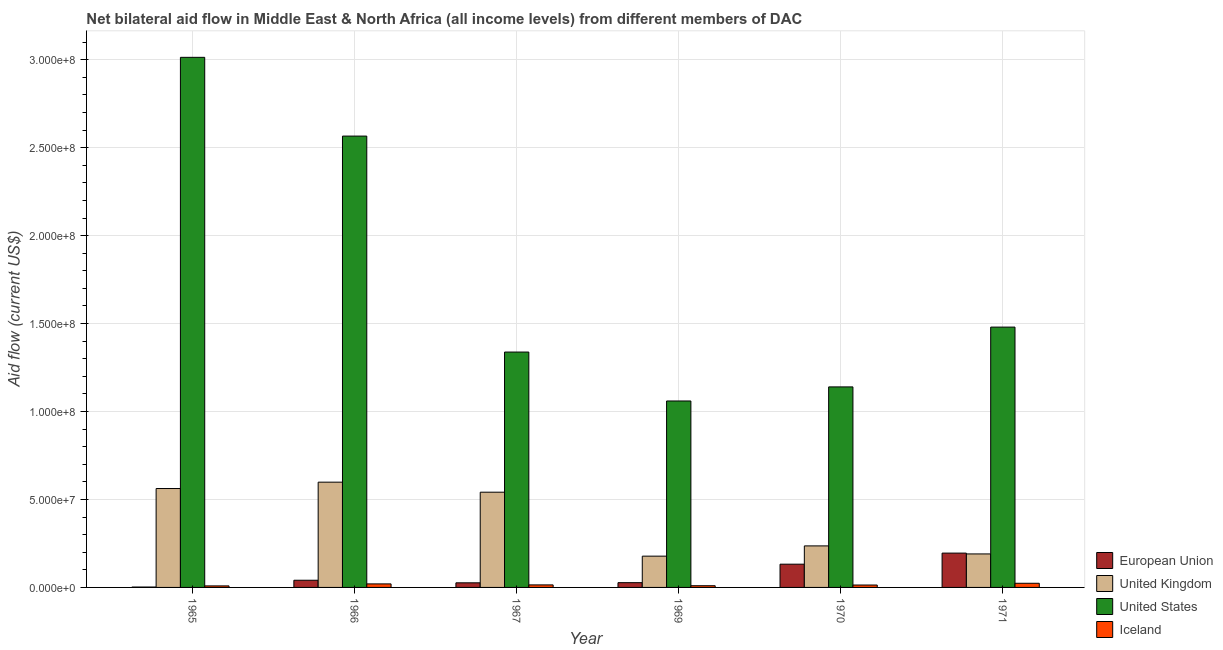How many groups of bars are there?
Your response must be concise. 6. How many bars are there on the 6th tick from the right?
Your answer should be compact. 4. What is the label of the 1st group of bars from the left?
Ensure brevity in your answer.  1965. In how many cases, is the number of bars for a given year not equal to the number of legend labels?
Your answer should be compact. 0. What is the amount of aid given by uk in 1965?
Ensure brevity in your answer.  5.62e+07. Across all years, what is the maximum amount of aid given by uk?
Offer a very short reply. 5.98e+07. Across all years, what is the minimum amount of aid given by eu?
Make the answer very short. 2.20e+05. In which year was the amount of aid given by us maximum?
Your answer should be very brief. 1965. In which year was the amount of aid given by eu minimum?
Ensure brevity in your answer.  1965. What is the total amount of aid given by uk in the graph?
Ensure brevity in your answer.  2.31e+08. What is the difference between the amount of aid given by uk in 1970 and that in 1971?
Provide a short and direct response. 4.57e+06. What is the difference between the amount of aid given by us in 1970 and the amount of aid given by uk in 1966?
Provide a short and direct response. -1.43e+08. What is the average amount of aid given by us per year?
Make the answer very short. 1.77e+08. In how many years, is the amount of aid given by iceland greater than 190000000 US$?
Your response must be concise. 0. What is the ratio of the amount of aid given by us in 1970 to that in 1971?
Ensure brevity in your answer.  0.77. What is the difference between the highest and the second highest amount of aid given by us?
Provide a short and direct response. 4.48e+07. What is the difference between the highest and the lowest amount of aid given by iceland?
Ensure brevity in your answer.  1.49e+06. Is it the case that in every year, the sum of the amount of aid given by uk and amount of aid given by eu is greater than the sum of amount of aid given by us and amount of aid given by iceland?
Make the answer very short. No. What does the 1st bar from the left in 1965 represents?
Your answer should be very brief. European Union. Is it the case that in every year, the sum of the amount of aid given by eu and amount of aid given by uk is greater than the amount of aid given by us?
Your answer should be compact. No. What is the difference between two consecutive major ticks on the Y-axis?
Offer a terse response. 5.00e+07. How are the legend labels stacked?
Your answer should be compact. Vertical. What is the title of the graph?
Your response must be concise. Net bilateral aid flow in Middle East & North Africa (all income levels) from different members of DAC. Does "Environmental sustainability" appear as one of the legend labels in the graph?
Make the answer very short. No. What is the label or title of the X-axis?
Your answer should be very brief. Year. What is the Aid flow (current US$) in European Union in 1965?
Your answer should be very brief. 2.20e+05. What is the Aid flow (current US$) in United Kingdom in 1965?
Provide a succinct answer. 5.62e+07. What is the Aid flow (current US$) in United States in 1965?
Make the answer very short. 3.01e+08. What is the Aid flow (current US$) in Iceland in 1965?
Give a very brief answer. 8.70e+05. What is the Aid flow (current US$) in European Union in 1966?
Offer a terse response. 4.08e+06. What is the Aid flow (current US$) in United Kingdom in 1966?
Keep it short and to the point. 5.98e+07. What is the Aid flow (current US$) in United States in 1966?
Your answer should be compact. 2.57e+08. What is the Aid flow (current US$) of Iceland in 1966?
Provide a short and direct response. 2.01e+06. What is the Aid flow (current US$) in European Union in 1967?
Ensure brevity in your answer.  2.62e+06. What is the Aid flow (current US$) in United Kingdom in 1967?
Provide a short and direct response. 5.41e+07. What is the Aid flow (current US$) of United States in 1967?
Ensure brevity in your answer.  1.34e+08. What is the Aid flow (current US$) of Iceland in 1967?
Your answer should be very brief. 1.44e+06. What is the Aid flow (current US$) in European Union in 1969?
Your answer should be compact. 2.71e+06. What is the Aid flow (current US$) in United Kingdom in 1969?
Ensure brevity in your answer.  1.78e+07. What is the Aid flow (current US$) in United States in 1969?
Offer a terse response. 1.06e+08. What is the Aid flow (current US$) in Iceland in 1969?
Offer a very short reply. 9.70e+05. What is the Aid flow (current US$) of European Union in 1970?
Your answer should be compact. 1.32e+07. What is the Aid flow (current US$) in United Kingdom in 1970?
Ensure brevity in your answer.  2.36e+07. What is the Aid flow (current US$) of United States in 1970?
Keep it short and to the point. 1.14e+08. What is the Aid flow (current US$) in Iceland in 1970?
Make the answer very short. 1.37e+06. What is the Aid flow (current US$) of European Union in 1971?
Your answer should be very brief. 1.95e+07. What is the Aid flow (current US$) in United Kingdom in 1971?
Your response must be concise. 1.90e+07. What is the Aid flow (current US$) in United States in 1971?
Keep it short and to the point. 1.48e+08. What is the Aid flow (current US$) in Iceland in 1971?
Your answer should be compact. 2.36e+06. Across all years, what is the maximum Aid flow (current US$) in European Union?
Your response must be concise. 1.95e+07. Across all years, what is the maximum Aid flow (current US$) in United Kingdom?
Your answer should be compact. 5.98e+07. Across all years, what is the maximum Aid flow (current US$) in United States?
Give a very brief answer. 3.01e+08. Across all years, what is the maximum Aid flow (current US$) of Iceland?
Offer a terse response. 2.36e+06. Across all years, what is the minimum Aid flow (current US$) of European Union?
Your answer should be very brief. 2.20e+05. Across all years, what is the minimum Aid flow (current US$) of United Kingdom?
Your answer should be compact. 1.78e+07. Across all years, what is the minimum Aid flow (current US$) of United States?
Ensure brevity in your answer.  1.06e+08. Across all years, what is the minimum Aid flow (current US$) of Iceland?
Provide a succinct answer. 8.70e+05. What is the total Aid flow (current US$) in European Union in the graph?
Provide a succinct answer. 4.24e+07. What is the total Aid flow (current US$) of United Kingdom in the graph?
Your answer should be very brief. 2.31e+08. What is the total Aid flow (current US$) of United States in the graph?
Give a very brief answer. 1.06e+09. What is the total Aid flow (current US$) of Iceland in the graph?
Offer a very short reply. 9.02e+06. What is the difference between the Aid flow (current US$) of European Union in 1965 and that in 1966?
Make the answer very short. -3.86e+06. What is the difference between the Aid flow (current US$) of United Kingdom in 1965 and that in 1966?
Provide a succinct answer. -3.61e+06. What is the difference between the Aid flow (current US$) of United States in 1965 and that in 1966?
Give a very brief answer. 4.48e+07. What is the difference between the Aid flow (current US$) in Iceland in 1965 and that in 1966?
Your response must be concise. -1.14e+06. What is the difference between the Aid flow (current US$) in European Union in 1965 and that in 1967?
Offer a terse response. -2.40e+06. What is the difference between the Aid flow (current US$) in United Kingdom in 1965 and that in 1967?
Give a very brief answer. 2.09e+06. What is the difference between the Aid flow (current US$) of United States in 1965 and that in 1967?
Your answer should be compact. 1.68e+08. What is the difference between the Aid flow (current US$) of Iceland in 1965 and that in 1967?
Offer a very short reply. -5.70e+05. What is the difference between the Aid flow (current US$) of European Union in 1965 and that in 1969?
Give a very brief answer. -2.49e+06. What is the difference between the Aid flow (current US$) in United Kingdom in 1965 and that in 1969?
Your answer should be very brief. 3.84e+07. What is the difference between the Aid flow (current US$) of United States in 1965 and that in 1969?
Provide a short and direct response. 1.95e+08. What is the difference between the Aid flow (current US$) in Iceland in 1965 and that in 1969?
Make the answer very short. -1.00e+05. What is the difference between the Aid flow (current US$) in European Union in 1965 and that in 1970?
Offer a terse response. -1.30e+07. What is the difference between the Aid flow (current US$) of United Kingdom in 1965 and that in 1970?
Offer a very short reply. 3.26e+07. What is the difference between the Aid flow (current US$) of United States in 1965 and that in 1970?
Provide a succinct answer. 1.87e+08. What is the difference between the Aid flow (current US$) in Iceland in 1965 and that in 1970?
Your answer should be compact. -5.00e+05. What is the difference between the Aid flow (current US$) in European Union in 1965 and that in 1971?
Your response must be concise. -1.93e+07. What is the difference between the Aid flow (current US$) in United Kingdom in 1965 and that in 1971?
Give a very brief answer. 3.72e+07. What is the difference between the Aid flow (current US$) of United States in 1965 and that in 1971?
Your answer should be compact. 1.53e+08. What is the difference between the Aid flow (current US$) in Iceland in 1965 and that in 1971?
Give a very brief answer. -1.49e+06. What is the difference between the Aid flow (current US$) in European Union in 1966 and that in 1967?
Make the answer very short. 1.46e+06. What is the difference between the Aid flow (current US$) in United Kingdom in 1966 and that in 1967?
Offer a very short reply. 5.70e+06. What is the difference between the Aid flow (current US$) in United States in 1966 and that in 1967?
Give a very brief answer. 1.23e+08. What is the difference between the Aid flow (current US$) of Iceland in 1966 and that in 1967?
Your answer should be very brief. 5.70e+05. What is the difference between the Aid flow (current US$) of European Union in 1966 and that in 1969?
Offer a terse response. 1.37e+06. What is the difference between the Aid flow (current US$) in United Kingdom in 1966 and that in 1969?
Make the answer very short. 4.21e+07. What is the difference between the Aid flow (current US$) of United States in 1966 and that in 1969?
Your response must be concise. 1.51e+08. What is the difference between the Aid flow (current US$) of Iceland in 1966 and that in 1969?
Provide a short and direct response. 1.04e+06. What is the difference between the Aid flow (current US$) in European Union in 1966 and that in 1970?
Offer a terse response. -9.14e+06. What is the difference between the Aid flow (current US$) of United Kingdom in 1966 and that in 1970?
Offer a terse response. 3.62e+07. What is the difference between the Aid flow (current US$) in United States in 1966 and that in 1970?
Give a very brief answer. 1.43e+08. What is the difference between the Aid flow (current US$) in Iceland in 1966 and that in 1970?
Your answer should be compact. 6.40e+05. What is the difference between the Aid flow (current US$) in European Union in 1966 and that in 1971?
Give a very brief answer. -1.54e+07. What is the difference between the Aid flow (current US$) of United Kingdom in 1966 and that in 1971?
Offer a very short reply. 4.08e+07. What is the difference between the Aid flow (current US$) of United States in 1966 and that in 1971?
Provide a short and direct response. 1.09e+08. What is the difference between the Aid flow (current US$) of Iceland in 1966 and that in 1971?
Ensure brevity in your answer.  -3.50e+05. What is the difference between the Aid flow (current US$) in United Kingdom in 1967 and that in 1969?
Give a very brief answer. 3.64e+07. What is the difference between the Aid flow (current US$) in United States in 1967 and that in 1969?
Keep it short and to the point. 2.78e+07. What is the difference between the Aid flow (current US$) in European Union in 1967 and that in 1970?
Ensure brevity in your answer.  -1.06e+07. What is the difference between the Aid flow (current US$) of United Kingdom in 1967 and that in 1970?
Offer a terse response. 3.05e+07. What is the difference between the Aid flow (current US$) in United States in 1967 and that in 1970?
Your response must be concise. 1.98e+07. What is the difference between the Aid flow (current US$) of European Union in 1967 and that in 1971?
Offer a terse response. -1.69e+07. What is the difference between the Aid flow (current US$) in United Kingdom in 1967 and that in 1971?
Offer a terse response. 3.51e+07. What is the difference between the Aid flow (current US$) in United States in 1967 and that in 1971?
Make the answer very short. -1.42e+07. What is the difference between the Aid flow (current US$) in Iceland in 1967 and that in 1971?
Make the answer very short. -9.20e+05. What is the difference between the Aid flow (current US$) in European Union in 1969 and that in 1970?
Offer a very short reply. -1.05e+07. What is the difference between the Aid flow (current US$) in United Kingdom in 1969 and that in 1970?
Your answer should be compact. -5.83e+06. What is the difference between the Aid flow (current US$) in United States in 1969 and that in 1970?
Keep it short and to the point. -8.00e+06. What is the difference between the Aid flow (current US$) in Iceland in 1969 and that in 1970?
Give a very brief answer. -4.00e+05. What is the difference between the Aid flow (current US$) of European Union in 1969 and that in 1971?
Keep it short and to the point. -1.68e+07. What is the difference between the Aid flow (current US$) in United Kingdom in 1969 and that in 1971?
Give a very brief answer. -1.26e+06. What is the difference between the Aid flow (current US$) of United States in 1969 and that in 1971?
Your answer should be compact. -4.20e+07. What is the difference between the Aid flow (current US$) in Iceland in 1969 and that in 1971?
Make the answer very short. -1.39e+06. What is the difference between the Aid flow (current US$) of European Union in 1970 and that in 1971?
Provide a short and direct response. -6.29e+06. What is the difference between the Aid flow (current US$) in United Kingdom in 1970 and that in 1971?
Your answer should be compact. 4.57e+06. What is the difference between the Aid flow (current US$) of United States in 1970 and that in 1971?
Your answer should be compact. -3.40e+07. What is the difference between the Aid flow (current US$) in Iceland in 1970 and that in 1971?
Keep it short and to the point. -9.90e+05. What is the difference between the Aid flow (current US$) in European Union in 1965 and the Aid flow (current US$) in United Kingdom in 1966?
Offer a very short reply. -5.96e+07. What is the difference between the Aid flow (current US$) in European Union in 1965 and the Aid flow (current US$) in United States in 1966?
Your answer should be compact. -2.56e+08. What is the difference between the Aid flow (current US$) of European Union in 1965 and the Aid flow (current US$) of Iceland in 1966?
Provide a succinct answer. -1.79e+06. What is the difference between the Aid flow (current US$) in United Kingdom in 1965 and the Aid flow (current US$) in United States in 1966?
Make the answer very short. -2.00e+08. What is the difference between the Aid flow (current US$) in United Kingdom in 1965 and the Aid flow (current US$) in Iceland in 1966?
Your response must be concise. 5.42e+07. What is the difference between the Aid flow (current US$) of United States in 1965 and the Aid flow (current US$) of Iceland in 1966?
Make the answer very short. 2.99e+08. What is the difference between the Aid flow (current US$) of European Union in 1965 and the Aid flow (current US$) of United Kingdom in 1967?
Make the answer very short. -5.39e+07. What is the difference between the Aid flow (current US$) in European Union in 1965 and the Aid flow (current US$) in United States in 1967?
Provide a succinct answer. -1.34e+08. What is the difference between the Aid flow (current US$) in European Union in 1965 and the Aid flow (current US$) in Iceland in 1967?
Ensure brevity in your answer.  -1.22e+06. What is the difference between the Aid flow (current US$) of United Kingdom in 1965 and the Aid flow (current US$) of United States in 1967?
Make the answer very short. -7.76e+07. What is the difference between the Aid flow (current US$) in United Kingdom in 1965 and the Aid flow (current US$) in Iceland in 1967?
Provide a short and direct response. 5.48e+07. What is the difference between the Aid flow (current US$) in United States in 1965 and the Aid flow (current US$) in Iceland in 1967?
Keep it short and to the point. 3.00e+08. What is the difference between the Aid flow (current US$) of European Union in 1965 and the Aid flow (current US$) of United Kingdom in 1969?
Offer a terse response. -1.76e+07. What is the difference between the Aid flow (current US$) of European Union in 1965 and the Aid flow (current US$) of United States in 1969?
Ensure brevity in your answer.  -1.06e+08. What is the difference between the Aid flow (current US$) in European Union in 1965 and the Aid flow (current US$) in Iceland in 1969?
Keep it short and to the point. -7.50e+05. What is the difference between the Aid flow (current US$) of United Kingdom in 1965 and the Aid flow (current US$) of United States in 1969?
Give a very brief answer. -4.98e+07. What is the difference between the Aid flow (current US$) of United Kingdom in 1965 and the Aid flow (current US$) of Iceland in 1969?
Keep it short and to the point. 5.53e+07. What is the difference between the Aid flow (current US$) in United States in 1965 and the Aid flow (current US$) in Iceland in 1969?
Provide a succinct answer. 3.00e+08. What is the difference between the Aid flow (current US$) of European Union in 1965 and the Aid flow (current US$) of United Kingdom in 1970?
Your answer should be very brief. -2.34e+07. What is the difference between the Aid flow (current US$) of European Union in 1965 and the Aid flow (current US$) of United States in 1970?
Offer a terse response. -1.14e+08. What is the difference between the Aid flow (current US$) of European Union in 1965 and the Aid flow (current US$) of Iceland in 1970?
Provide a short and direct response. -1.15e+06. What is the difference between the Aid flow (current US$) in United Kingdom in 1965 and the Aid flow (current US$) in United States in 1970?
Provide a succinct answer. -5.78e+07. What is the difference between the Aid flow (current US$) of United Kingdom in 1965 and the Aid flow (current US$) of Iceland in 1970?
Give a very brief answer. 5.49e+07. What is the difference between the Aid flow (current US$) of United States in 1965 and the Aid flow (current US$) of Iceland in 1970?
Ensure brevity in your answer.  3.00e+08. What is the difference between the Aid flow (current US$) of European Union in 1965 and the Aid flow (current US$) of United Kingdom in 1971?
Your answer should be compact. -1.88e+07. What is the difference between the Aid flow (current US$) in European Union in 1965 and the Aid flow (current US$) in United States in 1971?
Give a very brief answer. -1.48e+08. What is the difference between the Aid flow (current US$) of European Union in 1965 and the Aid flow (current US$) of Iceland in 1971?
Your answer should be very brief. -2.14e+06. What is the difference between the Aid flow (current US$) in United Kingdom in 1965 and the Aid flow (current US$) in United States in 1971?
Your answer should be compact. -9.18e+07. What is the difference between the Aid flow (current US$) of United Kingdom in 1965 and the Aid flow (current US$) of Iceland in 1971?
Keep it short and to the point. 5.39e+07. What is the difference between the Aid flow (current US$) in United States in 1965 and the Aid flow (current US$) in Iceland in 1971?
Make the answer very short. 2.99e+08. What is the difference between the Aid flow (current US$) in European Union in 1966 and the Aid flow (current US$) in United Kingdom in 1967?
Give a very brief answer. -5.01e+07. What is the difference between the Aid flow (current US$) in European Union in 1966 and the Aid flow (current US$) in United States in 1967?
Your response must be concise. -1.30e+08. What is the difference between the Aid flow (current US$) in European Union in 1966 and the Aid flow (current US$) in Iceland in 1967?
Your answer should be compact. 2.64e+06. What is the difference between the Aid flow (current US$) of United Kingdom in 1966 and the Aid flow (current US$) of United States in 1967?
Provide a succinct answer. -7.40e+07. What is the difference between the Aid flow (current US$) in United Kingdom in 1966 and the Aid flow (current US$) in Iceland in 1967?
Your answer should be compact. 5.84e+07. What is the difference between the Aid flow (current US$) of United States in 1966 and the Aid flow (current US$) of Iceland in 1967?
Offer a terse response. 2.55e+08. What is the difference between the Aid flow (current US$) in European Union in 1966 and the Aid flow (current US$) in United Kingdom in 1969?
Offer a terse response. -1.37e+07. What is the difference between the Aid flow (current US$) in European Union in 1966 and the Aid flow (current US$) in United States in 1969?
Provide a short and direct response. -1.02e+08. What is the difference between the Aid flow (current US$) in European Union in 1966 and the Aid flow (current US$) in Iceland in 1969?
Your answer should be compact. 3.11e+06. What is the difference between the Aid flow (current US$) of United Kingdom in 1966 and the Aid flow (current US$) of United States in 1969?
Your answer should be very brief. -4.62e+07. What is the difference between the Aid flow (current US$) of United Kingdom in 1966 and the Aid flow (current US$) of Iceland in 1969?
Give a very brief answer. 5.89e+07. What is the difference between the Aid flow (current US$) of United States in 1966 and the Aid flow (current US$) of Iceland in 1969?
Offer a terse response. 2.56e+08. What is the difference between the Aid flow (current US$) of European Union in 1966 and the Aid flow (current US$) of United Kingdom in 1970?
Provide a short and direct response. -1.95e+07. What is the difference between the Aid flow (current US$) of European Union in 1966 and the Aid flow (current US$) of United States in 1970?
Offer a terse response. -1.10e+08. What is the difference between the Aid flow (current US$) of European Union in 1966 and the Aid flow (current US$) of Iceland in 1970?
Provide a succinct answer. 2.71e+06. What is the difference between the Aid flow (current US$) in United Kingdom in 1966 and the Aid flow (current US$) in United States in 1970?
Your answer should be very brief. -5.42e+07. What is the difference between the Aid flow (current US$) in United Kingdom in 1966 and the Aid flow (current US$) in Iceland in 1970?
Keep it short and to the point. 5.85e+07. What is the difference between the Aid flow (current US$) of United States in 1966 and the Aid flow (current US$) of Iceland in 1970?
Your answer should be compact. 2.55e+08. What is the difference between the Aid flow (current US$) in European Union in 1966 and the Aid flow (current US$) in United Kingdom in 1971?
Offer a very short reply. -1.50e+07. What is the difference between the Aid flow (current US$) in European Union in 1966 and the Aid flow (current US$) in United States in 1971?
Your response must be concise. -1.44e+08. What is the difference between the Aid flow (current US$) in European Union in 1966 and the Aid flow (current US$) in Iceland in 1971?
Keep it short and to the point. 1.72e+06. What is the difference between the Aid flow (current US$) in United Kingdom in 1966 and the Aid flow (current US$) in United States in 1971?
Your response must be concise. -8.82e+07. What is the difference between the Aid flow (current US$) of United Kingdom in 1966 and the Aid flow (current US$) of Iceland in 1971?
Provide a short and direct response. 5.75e+07. What is the difference between the Aid flow (current US$) in United States in 1966 and the Aid flow (current US$) in Iceland in 1971?
Provide a short and direct response. 2.54e+08. What is the difference between the Aid flow (current US$) of European Union in 1967 and the Aid flow (current US$) of United Kingdom in 1969?
Give a very brief answer. -1.52e+07. What is the difference between the Aid flow (current US$) of European Union in 1967 and the Aid flow (current US$) of United States in 1969?
Offer a terse response. -1.03e+08. What is the difference between the Aid flow (current US$) of European Union in 1967 and the Aid flow (current US$) of Iceland in 1969?
Give a very brief answer. 1.65e+06. What is the difference between the Aid flow (current US$) of United Kingdom in 1967 and the Aid flow (current US$) of United States in 1969?
Provide a short and direct response. -5.19e+07. What is the difference between the Aid flow (current US$) in United Kingdom in 1967 and the Aid flow (current US$) in Iceland in 1969?
Offer a very short reply. 5.32e+07. What is the difference between the Aid flow (current US$) of United States in 1967 and the Aid flow (current US$) of Iceland in 1969?
Keep it short and to the point. 1.33e+08. What is the difference between the Aid flow (current US$) in European Union in 1967 and the Aid flow (current US$) in United Kingdom in 1970?
Ensure brevity in your answer.  -2.10e+07. What is the difference between the Aid flow (current US$) of European Union in 1967 and the Aid flow (current US$) of United States in 1970?
Make the answer very short. -1.11e+08. What is the difference between the Aid flow (current US$) of European Union in 1967 and the Aid flow (current US$) of Iceland in 1970?
Ensure brevity in your answer.  1.25e+06. What is the difference between the Aid flow (current US$) in United Kingdom in 1967 and the Aid flow (current US$) in United States in 1970?
Make the answer very short. -5.99e+07. What is the difference between the Aid flow (current US$) of United Kingdom in 1967 and the Aid flow (current US$) of Iceland in 1970?
Provide a succinct answer. 5.28e+07. What is the difference between the Aid flow (current US$) of United States in 1967 and the Aid flow (current US$) of Iceland in 1970?
Your answer should be compact. 1.32e+08. What is the difference between the Aid flow (current US$) in European Union in 1967 and the Aid flow (current US$) in United Kingdom in 1971?
Give a very brief answer. -1.64e+07. What is the difference between the Aid flow (current US$) of European Union in 1967 and the Aid flow (current US$) of United States in 1971?
Your answer should be very brief. -1.45e+08. What is the difference between the Aid flow (current US$) of United Kingdom in 1967 and the Aid flow (current US$) of United States in 1971?
Provide a short and direct response. -9.39e+07. What is the difference between the Aid flow (current US$) of United Kingdom in 1967 and the Aid flow (current US$) of Iceland in 1971?
Offer a very short reply. 5.18e+07. What is the difference between the Aid flow (current US$) in United States in 1967 and the Aid flow (current US$) in Iceland in 1971?
Provide a succinct answer. 1.31e+08. What is the difference between the Aid flow (current US$) in European Union in 1969 and the Aid flow (current US$) in United Kingdom in 1970?
Give a very brief answer. -2.09e+07. What is the difference between the Aid flow (current US$) of European Union in 1969 and the Aid flow (current US$) of United States in 1970?
Ensure brevity in your answer.  -1.11e+08. What is the difference between the Aid flow (current US$) of European Union in 1969 and the Aid flow (current US$) of Iceland in 1970?
Provide a short and direct response. 1.34e+06. What is the difference between the Aid flow (current US$) in United Kingdom in 1969 and the Aid flow (current US$) in United States in 1970?
Provide a short and direct response. -9.62e+07. What is the difference between the Aid flow (current US$) in United Kingdom in 1969 and the Aid flow (current US$) in Iceland in 1970?
Provide a short and direct response. 1.64e+07. What is the difference between the Aid flow (current US$) in United States in 1969 and the Aid flow (current US$) in Iceland in 1970?
Provide a short and direct response. 1.05e+08. What is the difference between the Aid flow (current US$) in European Union in 1969 and the Aid flow (current US$) in United Kingdom in 1971?
Provide a short and direct response. -1.63e+07. What is the difference between the Aid flow (current US$) in European Union in 1969 and the Aid flow (current US$) in United States in 1971?
Offer a terse response. -1.45e+08. What is the difference between the Aid flow (current US$) of European Union in 1969 and the Aid flow (current US$) of Iceland in 1971?
Provide a short and direct response. 3.50e+05. What is the difference between the Aid flow (current US$) of United Kingdom in 1969 and the Aid flow (current US$) of United States in 1971?
Offer a terse response. -1.30e+08. What is the difference between the Aid flow (current US$) of United Kingdom in 1969 and the Aid flow (current US$) of Iceland in 1971?
Make the answer very short. 1.54e+07. What is the difference between the Aid flow (current US$) of United States in 1969 and the Aid flow (current US$) of Iceland in 1971?
Make the answer very short. 1.04e+08. What is the difference between the Aid flow (current US$) in European Union in 1970 and the Aid flow (current US$) in United Kingdom in 1971?
Provide a succinct answer. -5.82e+06. What is the difference between the Aid flow (current US$) in European Union in 1970 and the Aid flow (current US$) in United States in 1971?
Give a very brief answer. -1.35e+08. What is the difference between the Aid flow (current US$) of European Union in 1970 and the Aid flow (current US$) of Iceland in 1971?
Give a very brief answer. 1.09e+07. What is the difference between the Aid flow (current US$) in United Kingdom in 1970 and the Aid flow (current US$) in United States in 1971?
Provide a short and direct response. -1.24e+08. What is the difference between the Aid flow (current US$) of United Kingdom in 1970 and the Aid flow (current US$) of Iceland in 1971?
Keep it short and to the point. 2.12e+07. What is the difference between the Aid flow (current US$) of United States in 1970 and the Aid flow (current US$) of Iceland in 1971?
Provide a short and direct response. 1.12e+08. What is the average Aid flow (current US$) of European Union per year?
Keep it short and to the point. 7.06e+06. What is the average Aid flow (current US$) in United Kingdom per year?
Provide a succinct answer. 3.84e+07. What is the average Aid flow (current US$) in United States per year?
Provide a short and direct response. 1.77e+08. What is the average Aid flow (current US$) of Iceland per year?
Make the answer very short. 1.50e+06. In the year 1965, what is the difference between the Aid flow (current US$) of European Union and Aid flow (current US$) of United Kingdom?
Ensure brevity in your answer.  -5.60e+07. In the year 1965, what is the difference between the Aid flow (current US$) of European Union and Aid flow (current US$) of United States?
Your answer should be very brief. -3.01e+08. In the year 1965, what is the difference between the Aid flow (current US$) of European Union and Aid flow (current US$) of Iceland?
Your answer should be very brief. -6.50e+05. In the year 1965, what is the difference between the Aid flow (current US$) in United Kingdom and Aid flow (current US$) in United States?
Provide a short and direct response. -2.45e+08. In the year 1965, what is the difference between the Aid flow (current US$) in United Kingdom and Aid flow (current US$) in Iceland?
Give a very brief answer. 5.54e+07. In the year 1965, what is the difference between the Aid flow (current US$) of United States and Aid flow (current US$) of Iceland?
Give a very brief answer. 3.00e+08. In the year 1966, what is the difference between the Aid flow (current US$) of European Union and Aid flow (current US$) of United Kingdom?
Make the answer very short. -5.58e+07. In the year 1966, what is the difference between the Aid flow (current US$) in European Union and Aid flow (current US$) in United States?
Offer a terse response. -2.53e+08. In the year 1966, what is the difference between the Aid flow (current US$) in European Union and Aid flow (current US$) in Iceland?
Make the answer very short. 2.07e+06. In the year 1966, what is the difference between the Aid flow (current US$) of United Kingdom and Aid flow (current US$) of United States?
Provide a short and direct response. -1.97e+08. In the year 1966, what is the difference between the Aid flow (current US$) of United Kingdom and Aid flow (current US$) of Iceland?
Give a very brief answer. 5.78e+07. In the year 1966, what is the difference between the Aid flow (current US$) in United States and Aid flow (current US$) in Iceland?
Make the answer very short. 2.55e+08. In the year 1967, what is the difference between the Aid flow (current US$) of European Union and Aid flow (current US$) of United Kingdom?
Provide a short and direct response. -5.15e+07. In the year 1967, what is the difference between the Aid flow (current US$) in European Union and Aid flow (current US$) in United States?
Give a very brief answer. -1.31e+08. In the year 1967, what is the difference between the Aid flow (current US$) in European Union and Aid flow (current US$) in Iceland?
Make the answer very short. 1.18e+06. In the year 1967, what is the difference between the Aid flow (current US$) in United Kingdom and Aid flow (current US$) in United States?
Provide a short and direct response. -7.97e+07. In the year 1967, what is the difference between the Aid flow (current US$) of United Kingdom and Aid flow (current US$) of Iceland?
Provide a short and direct response. 5.27e+07. In the year 1967, what is the difference between the Aid flow (current US$) in United States and Aid flow (current US$) in Iceland?
Keep it short and to the point. 1.32e+08. In the year 1969, what is the difference between the Aid flow (current US$) in European Union and Aid flow (current US$) in United Kingdom?
Make the answer very short. -1.51e+07. In the year 1969, what is the difference between the Aid flow (current US$) of European Union and Aid flow (current US$) of United States?
Offer a terse response. -1.03e+08. In the year 1969, what is the difference between the Aid flow (current US$) of European Union and Aid flow (current US$) of Iceland?
Make the answer very short. 1.74e+06. In the year 1969, what is the difference between the Aid flow (current US$) in United Kingdom and Aid flow (current US$) in United States?
Offer a very short reply. -8.82e+07. In the year 1969, what is the difference between the Aid flow (current US$) in United Kingdom and Aid flow (current US$) in Iceland?
Offer a terse response. 1.68e+07. In the year 1969, what is the difference between the Aid flow (current US$) in United States and Aid flow (current US$) in Iceland?
Make the answer very short. 1.05e+08. In the year 1970, what is the difference between the Aid flow (current US$) of European Union and Aid flow (current US$) of United Kingdom?
Keep it short and to the point. -1.04e+07. In the year 1970, what is the difference between the Aid flow (current US$) of European Union and Aid flow (current US$) of United States?
Your answer should be very brief. -1.01e+08. In the year 1970, what is the difference between the Aid flow (current US$) in European Union and Aid flow (current US$) in Iceland?
Your answer should be compact. 1.18e+07. In the year 1970, what is the difference between the Aid flow (current US$) in United Kingdom and Aid flow (current US$) in United States?
Provide a short and direct response. -9.04e+07. In the year 1970, what is the difference between the Aid flow (current US$) in United Kingdom and Aid flow (current US$) in Iceland?
Offer a terse response. 2.22e+07. In the year 1970, what is the difference between the Aid flow (current US$) in United States and Aid flow (current US$) in Iceland?
Provide a short and direct response. 1.13e+08. In the year 1971, what is the difference between the Aid flow (current US$) in European Union and Aid flow (current US$) in United States?
Give a very brief answer. -1.28e+08. In the year 1971, what is the difference between the Aid flow (current US$) in European Union and Aid flow (current US$) in Iceland?
Keep it short and to the point. 1.72e+07. In the year 1971, what is the difference between the Aid flow (current US$) in United Kingdom and Aid flow (current US$) in United States?
Provide a short and direct response. -1.29e+08. In the year 1971, what is the difference between the Aid flow (current US$) in United Kingdom and Aid flow (current US$) in Iceland?
Provide a short and direct response. 1.67e+07. In the year 1971, what is the difference between the Aid flow (current US$) in United States and Aid flow (current US$) in Iceland?
Give a very brief answer. 1.46e+08. What is the ratio of the Aid flow (current US$) of European Union in 1965 to that in 1966?
Ensure brevity in your answer.  0.05. What is the ratio of the Aid flow (current US$) in United Kingdom in 1965 to that in 1966?
Offer a terse response. 0.94. What is the ratio of the Aid flow (current US$) in United States in 1965 to that in 1966?
Keep it short and to the point. 1.17. What is the ratio of the Aid flow (current US$) of Iceland in 1965 to that in 1966?
Provide a succinct answer. 0.43. What is the ratio of the Aid flow (current US$) in European Union in 1965 to that in 1967?
Make the answer very short. 0.08. What is the ratio of the Aid flow (current US$) of United Kingdom in 1965 to that in 1967?
Provide a short and direct response. 1.04. What is the ratio of the Aid flow (current US$) in United States in 1965 to that in 1967?
Your answer should be compact. 2.25. What is the ratio of the Aid flow (current US$) in Iceland in 1965 to that in 1967?
Your answer should be compact. 0.6. What is the ratio of the Aid flow (current US$) of European Union in 1965 to that in 1969?
Provide a succinct answer. 0.08. What is the ratio of the Aid flow (current US$) of United Kingdom in 1965 to that in 1969?
Keep it short and to the point. 3.16. What is the ratio of the Aid flow (current US$) of United States in 1965 to that in 1969?
Your answer should be very brief. 2.84. What is the ratio of the Aid flow (current US$) in Iceland in 1965 to that in 1969?
Your answer should be very brief. 0.9. What is the ratio of the Aid flow (current US$) in European Union in 1965 to that in 1970?
Provide a short and direct response. 0.02. What is the ratio of the Aid flow (current US$) in United Kingdom in 1965 to that in 1970?
Offer a very short reply. 2.38. What is the ratio of the Aid flow (current US$) in United States in 1965 to that in 1970?
Your answer should be compact. 2.64. What is the ratio of the Aid flow (current US$) of Iceland in 1965 to that in 1970?
Your response must be concise. 0.64. What is the ratio of the Aid flow (current US$) in European Union in 1965 to that in 1971?
Provide a succinct answer. 0.01. What is the ratio of the Aid flow (current US$) of United Kingdom in 1965 to that in 1971?
Offer a terse response. 2.95. What is the ratio of the Aid flow (current US$) of United States in 1965 to that in 1971?
Provide a short and direct response. 2.04. What is the ratio of the Aid flow (current US$) of Iceland in 1965 to that in 1971?
Provide a succinct answer. 0.37. What is the ratio of the Aid flow (current US$) in European Union in 1966 to that in 1967?
Offer a very short reply. 1.56. What is the ratio of the Aid flow (current US$) in United Kingdom in 1966 to that in 1967?
Give a very brief answer. 1.11. What is the ratio of the Aid flow (current US$) of United States in 1966 to that in 1967?
Offer a terse response. 1.92. What is the ratio of the Aid flow (current US$) of Iceland in 1966 to that in 1967?
Give a very brief answer. 1.4. What is the ratio of the Aid flow (current US$) in European Union in 1966 to that in 1969?
Give a very brief answer. 1.51. What is the ratio of the Aid flow (current US$) in United Kingdom in 1966 to that in 1969?
Your answer should be compact. 3.37. What is the ratio of the Aid flow (current US$) in United States in 1966 to that in 1969?
Your response must be concise. 2.42. What is the ratio of the Aid flow (current US$) in Iceland in 1966 to that in 1969?
Provide a succinct answer. 2.07. What is the ratio of the Aid flow (current US$) of European Union in 1966 to that in 1970?
Offer a terse response. 0.31. What is the ratio of the Aid flow (current US$) of United Kingdom in 1966 to that in 1970?
Ensure brevity in your answer.  2.53. What is the ratio of the Aid flow (current US$) of United States in 1966 to that in 1970?
Your response must be concise. 2.25. What is the ratio of the Aid flow (current US$) of Iceland in 1966 to that in 1970?
Your answer should be very brief. 1.47. What is the ratio of the Aid flow (current US$) in European Union in 1966 to that in 1971?
Your answer should be compact. 0.21. What is the ratio of the Aid flow (current US$) of United Kingdom in 1966 to that in 1971?
Your answer should be compact. 3.14. What is the ratio of the Aid flow (current US$) of United States in 1966 to that in 1971?
Your answer should be very brief. 1.73. What is the ratio of the Aid flow (current US$) of Iceland in 1966 to that in 1971?
Keep it short and to the point. 0.85. What is the ratio of the Aid flow (current US$) of European Union in 1967 to that in 1969?
Offer a terse response. 0.97. What is the ratio of the Aid flow (current US$) in United Kingdom in 1967 to that in 1969?
Provide a short and direct response. 3.04. What is the ratio of the Aid flow (current US$) of United States in 1967 to that in 1969?
Your response must be concise. 1.26. What is the ratio of the Aid flow (current US$) in Iceland in 1967 to that in 1969?
Offer a very short reply. 1.48. What is the ratio of the Aid flow (current US$) of European Union in 1967 to that in 1970?
Provide a succinct answer. 0.2. What is the ratio of the Aid flow (current US$) of United Kingdom in 1967 to that in 1970?
Offer a very short reply. 2.29. What is the ratio of the Aid flow (current US$) in United States in 1967 to that in 1970?
Your answer should be compact. 1.17. What is the ratio of the Aid flow (current US$) in Iceland in 1967 to that in 1970?
Keep it short and to the point. 1.05. What is the ratio of the Aid flow (current US$) of European Union in 1967 to that in 1971?
Ensure brevity in your answer.  0.13. What is the ratio of the Aid flow (current US$) of United Kingdom in 1967 to that in 1971?
Your answer should be very brief. 2.84. What is the ratio of the Aid flow (current US$) of United States in 1967 to that in 1971?
Give a very brief answer. 0.9. What is the ratio of the Aid flow (current US$) in Iceland in 1967 to that in 1971?
Give a very brief answer. 0.61. What is the ratio of the Aid flow (current US$) of European Union in 1969 to that in 1970?
Your response must be concise. 0.2. What is the ratio of the Aid flow (current US$) in United Kingdom in 1969 to that in 1970?
Provide a succinct answer. 0.75. What is the ratio of the Aid flow (current US$) of United States in 1969 to that in 1970?
Your response must be concise. 0.93. What is the ratio of the Aid flow (current US$) of Iceland in 1969 to that in 1970?
Ensure brevity in your answer.  0.71. What is the ratio of the Aid flow (current US$) in European Union in 1969 to that in 1971?
Make the answer very short. 0.14. What is the ratio of the Aid flow (current US$) in United Kingdom in 1969 to that in 1971?
Offer a terse response. 0.93. What is the ratio of the Aid flow (current US$) of United States in 1969 to that in 1971?
Make the answer very short. 0.72. What is the ratio of the Aid flow (current US$) in Iceland in 1969 to that in 1971?
Keep it short and to the point. 0.41. What is the ratio of the Aid flow (current US$) in European Union in 1970 to that in 1971?
Keep it short and to the point. 0.68. What is the ratio of the Aid flow (current US$) in United Kingdom in 1970 to that in 1971?
Provide a short and direct response. 1.24. What is the ratio of the Aid flow (current US$) in United States in 1970 to that in 1971?
Make the answer very short. 0.77. What is the ratio of the Aid flow (current US$) in Iceland in 1970 to that in 1971?
Your answer should be very brief. 0.58. What is the difference between the highest and the second highest Aid flow (current US$) in European Union?
Give a very brief answer. 6.29e+06. What is the difference between the highest and the second highest Aid flow (current US$) in United Kingdom?
Provide a short and direct response. 3.61e+06. What is the difference between the highest and the second highest Aid flow (current US$) in United States?
Offer a terse response. 4.48e+07. What is the difference between the highest and the second highest Aid flow (current US$) in Iceland?
Make the answer very short. 3.50e+05. What is the difference between the highest and the lowest Aid flow (current US$) of European Union?
Keep it short and to the point. 1.93e+07. What is the difference between the highest and the lowest Aid flow (current US$) in United Kingdom?
Your response must be concise. 4.21e+07. What is the difference between the highest and the lowest Aid flow (current US$) of United States?
Keep it short and to the point. 1.95e+08. What is the difference between the highest and the lowest Aid flow (current US$) of Iceland?
Offer a terse response. 1.49e+06. 